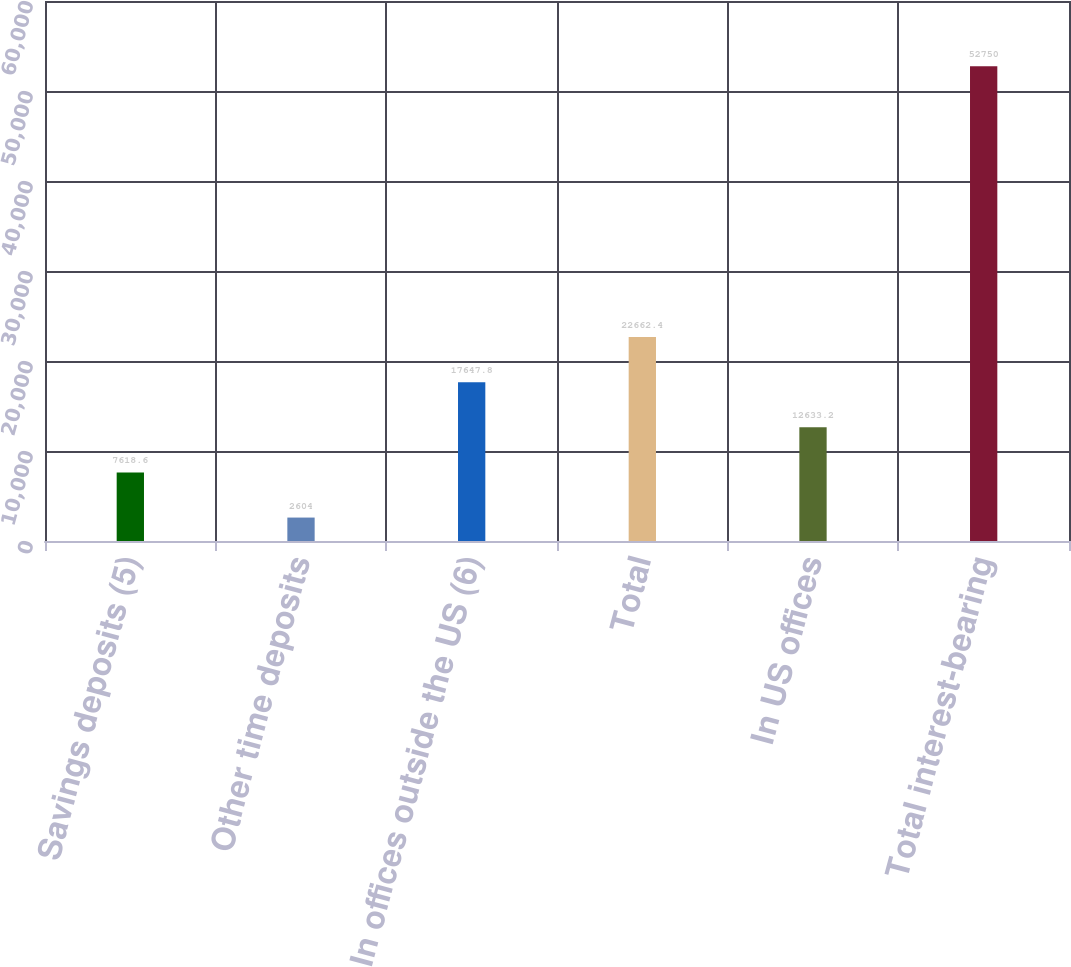<chart> <loc_0><loc_0><loc_500><loc_500><bar_chart><fcel>Savings deposits (5)<fcel>Other time deposits<fcel>In offices outside the US (6)<fcel>Total<fcel>In US offices<fcel>Total interest-bearing<nl><fcel>7618.6<fcel>2604<fcel>17647.8<fcel>22662.4<fcel>12633.2<fcel>52750<nl></chart> 